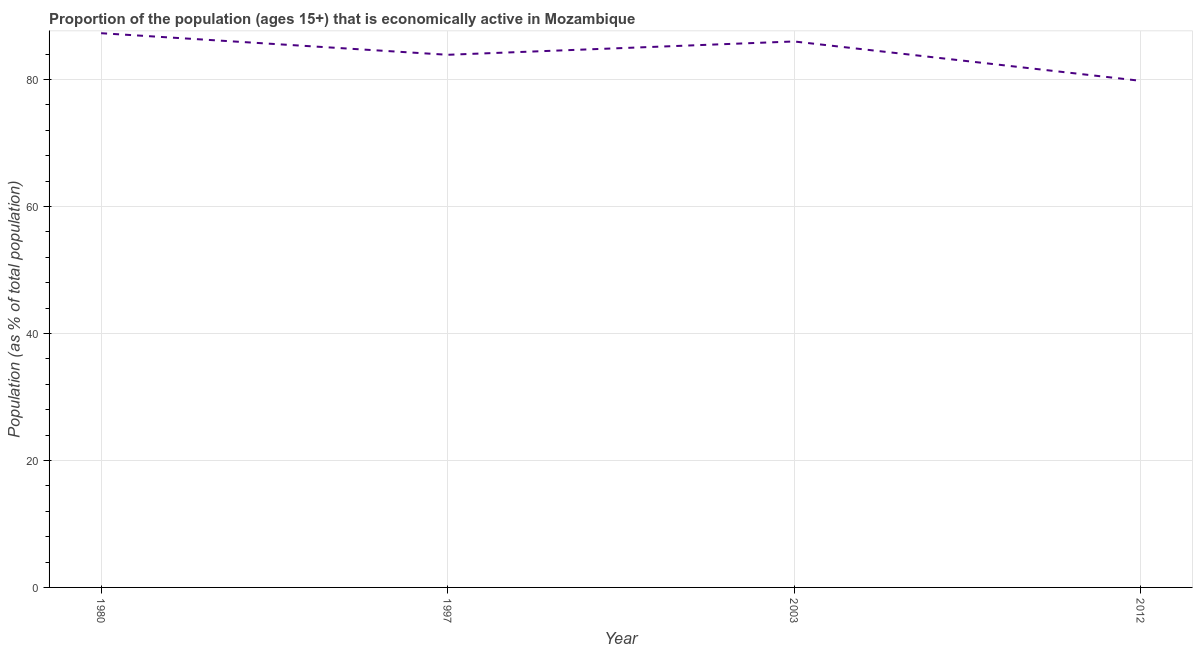What is the percentage of economically active population in 2012?
Your answer should be very brief. 79.8. Across all years, what is the maximum percentage of economically active population?
Ensure brevity in your answer.  87.3. Across all years, what is the minimum percentage of economically active population?
Your answer should be compact. 79.8. In which year was the percentage of economically active population minimum?
Your answer should be very brief. 2012. What is the sum of the percentage of economically active population?
Provide a succinct answer. 337. What is the difference between the percentage of economically active population in 1980 and 2003?
Your answer should be very brief. 1.3. What is the average percentage of economically active population per year?
Give a very brief answer. 84.25. What is the median percentage of economically active population?
Provide a short and direct response. 84.95. In how many years, is the percentage of economically active population greater than 20 %?
Give a very brief answer. 4. Do a majority of the years between 1997 and 1980 (inclusive) have percentage of economically active population greater than 44 %?
Give a very brief answer. No. What is the ratio of the percentage of economically active population in 1980 to that in 1997?
Your response must be concise. 1.04. What is the difference between the highest and the second highest percentage of economically active population?
Your response must be concise. 1.3. What is the difference between the highest and the lowest percentage of economically active population?
Offer a terse response. 7.5. Does the graph contain any zero values?
Your answer should be very brief. No. Does the graph contain grids?
Ensure brevity in your answer.  Yes. What is the title of the graph?
Make the answer very short. Proportion of the population (ages 15+) that is economically active in Mozambique. What is the label or title of the X-axis?
Offer a terse response. Year. What is the label or title of the Y-axis?
Offer a very short reply. Population (as % of total population). What is the Population (as % of total population) of 1980?
Offer a terse response. 87.3. What is the Population (as % of total population) in 1997?
Your answer should be compact. 83.9. What is the Population (as % of total population) of 2012?
Your response must be concise. 79.8. What is the difference between the Population (as % of total population) in 1980 and 1997?
Your answer should be very brief. 3.4. What is the difference between the Population (as % of total population) in 1980 and 2012?
Offer a very short reply. 7.5. What is the difference between the Population (as % of total population) in 1997 and 2012?
Provide a short and direct response. 4.1. What is the difference between the Population (as % of total population) in 2003 and 2012?
Give a very brief answer. 6.2. What is the ratio of the Population (as % of total population) in 1980 to that in 1997?
Provide a short and direct response. 1.04. What is the ratio of the Population (as % of total population) in 1980 to that in 2003?
Ensure brevity in your answer.  1.01. What is the ratio of the Population (as % of total population) in 1980 to that in 2012?
Offer a very short reply. 1.09. What is the ratio of the Population (as % of total population) in 1997 to that in 2003?
Keep it short and to the point. 0.98. What is the ratio of the Population (as % of total population) in 1997 to that in 2012?
Your answer should be very brief. 1.05. What is the ratio of the Population (as % of total population) in 2003 to that in 2012?
Provide a succinct answer. 1.08. 